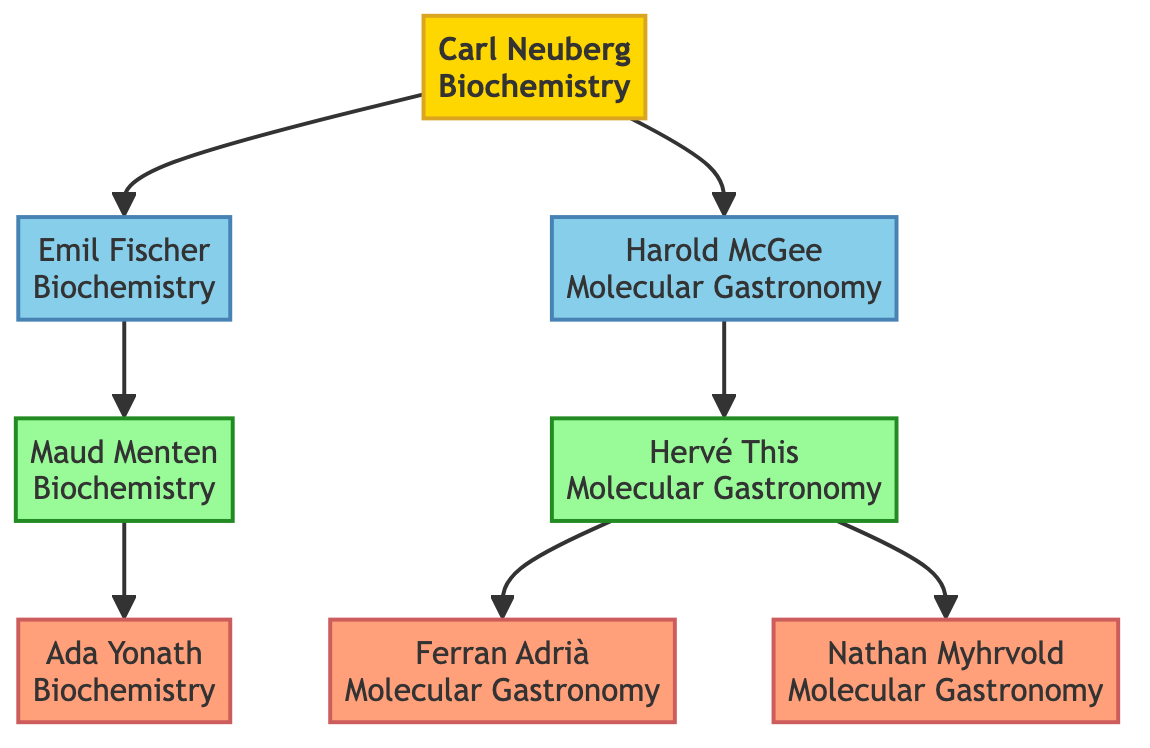What is the contribution of Carl Neuberg? The diagram indicates that Carl Neuberg is recognized as the "Father of modern biochemistry" and discovered the role of enzymes in chemical reactions.
Answer: Father of modern biochemistry, discovered the role of enzymes in chemical reactions Who are the pioneers in the field of molecular gastronomy? According to the diagram, Harold McGee is identified as the pioneer in molecular gastronomy, as he is the only one listed under this section apart from a biochemist.
Answer: Harold McGee Which generation does Ada Yonath belong to? By examining the diagram, it is clear that Ada Yonath is grouped under the "Fourth" generation, as indicated next to her name.
Answer: Fourth What is the relationship between Emil Fischer and Maud Menten? The diagram shows a direct relationship where Emil Fischer, belonging to the second generation, leads to Maud Menten, who is a third-generation figure. This indicates that Maud Menten is a descendant of Emil Fischer.
Answer: Emil Fischer is Maud Menten's predecessor How many modern influencers are there? Counting the individuals listed under the "modern influencers" section of the diagram, we find three: Ada Yonath, Ferran Adrià, and Nathan Myhrvold.
Answer: Three Who co-founded molecular gastronomy? The diagram states that Hervé This is a co-founder of molecular gastronomy, as noted in the contributions next to his name.
Answer: Hervé This Which figure has a contribution related to enzyme kinetics? Upon reviewing the information in the diagram, Maud Menten is noted for her "Fundamental work on enzyme kinetics," making her the relevant figure.
Answer: Maud Menten Which figure's work is associated with the Nobel Prize? The diagram specifies that Ada Yonath is recognized for receiving the Nobel Prize for her work in ribosome crystallography.
Answer: Ada Yonath What techniques did Hervé This develop? The diagram notes that Hervé This developed techniques such as spherification, making this the relevant answer.
Answer: Spherification 